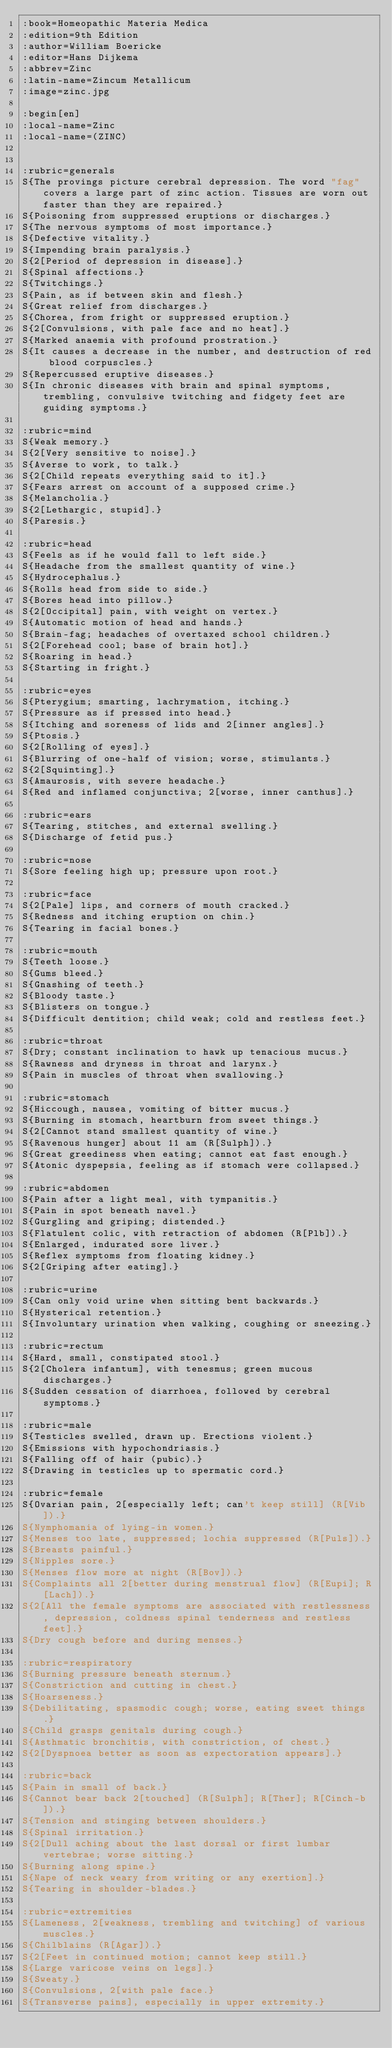<code> <loc_0><loc_0><loc_500><loc_500><_ObjectiveC_>:book=Homeopathic Materia Medica
:edition=9th Edition
:author=William Boericke
:editor=Hans Dijkema
:abbrev=Zinc
:latin-name=Zincum Metallicum
:image=zinc.jpg

:begin[en]
:local-name=Zinc
:local-name=(ZINC)


:rubric=generals
S{The provings picture cerebral depression. The word "fag" covers a large part of zinc action. Tissues are worn out faster than they are repaired.}
S{Poisoning from suppressed eruptions or discharges.}
S{The nervous symptoms of most importance.}
S{Defective vitality.}
S{Impending brain paralysis.}
S{2[Period of depression in disease].}
S{Spinal affections.}
S{Twitchings.}
S{Pain, as if between skin and flesh.}
S{Great relief from discharges.}
S{Chorea, from fright or suppressed eruption.}
S{2[Convulsions, with pale face and no heat].}
S{Marked anaemia with profound prostration.}
S{It causes a decrease in the number, and destruction of red blood corpuscles.}
S{Repercussed eruptive diseases.}
S{In chronic diseases with brain and spinal symptoms, trembling, convulsive twitching and fidgety feet are guiding symptoms.}

:rubric=mind
S{Weak memory.}
S{2[Very sensitive to noise].}
S{Averse to work, to talk.}
S{2[Child repeats everything said to it].}
S{Fears arrest on account of a supposed crime.}
S{Melancholia.}
S{2[Lethargic, stupid].}
S{Paresis.}

:rubric=head
S{Feels as if he would fall to left side.}
S{Headache from the smallest quantity of wine.}
S{Hydrocephalus.}
S{Rolls head from side to side.}
S{Bores head into pillow.}
S{2[Occipital] pain, with weight on vertex.}
S{Automatic motion of head and hands.}
S{Brain-fag; headaches of overtaxed school children.}
S{2[Forehead cool; base of brain hot].}
S{Roaring in head.}
S{Starting in fright.}

:rubric=eyes
S{Pterygium; smarting, lachrymation, itching.}
S{Pressure as if pressed into head.}
S{Itching and soreness of lids and 2[inner angles].}
S{Ptosis.}
S{2[Rolling of eyes].}
S{Blurring of one-half of vision; worse, stimulants.}
S{2[Squinting].}
S{Amaurosis, with severe headache.}
S{Red and inflamed conjunctiva; 2[worse, inner canthus].}

:rubric=ears
S{Tearing, stitches, and external swelling.}
S{Discharge of fetid pus.}

:rubric=nose
S{Sore feeling high up; pressure upon root.}

:rubric=face
S{2[Pale] lips, and corners of mouth cracked.}
S{Redness and itching eruption on chin.}
S{Tearing in facial bones.}

:rubric=mouth
S{Teeth loose.}
S{Gums bleed.}
S{Gnashing of teeth.}
S{Bloody taste.}
S{Blisters on tongue.}
S{Difficult dentition; child weak; cold and restless feet.}

:rubric=throat
S{Dry; constant inclination to hawk up tenacious mucus.}
S{Rawness and dryness in throat and larynx.}
S{Pain in muscles of throat when swallowing.}

:rubric=stomach
S{Hiccough, nausea, vomiting of bitter mucus.}
S{Burning in stomach, heartburn from sweet things.}
S{2[Cannot stand smallest quantity of wine.}
S{Ravenous hunger] about 11 am (R[Sulph]).}
S{Great greediness when eating; cannot eat fast enough.}
S{Atonic dyspepsia, feeling as if stomach were collapsed.}

:rubric=abdomen
S{Pain after a light meal, with tympanitis.}
S{Pain in spot beneath navel.}
S{Gurgling and griping; distended.}
S{Flatulent colic, with retraction of abdomen (R[Plb]).}
S{Enlarged, indurated sore liver.}
S{Reflex symptoms from floating kidney.}
S{2[Griping after eating].}

:rubric=urine
S{Can only void urine when sitting bent backwards.}
S{Hysterical retention.}
S{Involuntary urination when walking, coughing or sneezing.}

:rubric=rectum
S{Hard, small, constipated stool.}
S{2[Cholera infantum], with tenesmus; green mucous discharges.}
S{Sudden cessation of diarrhoea, followed by cerebral symptoms.}

:rubric=male
S{Testicles swelled, drawn up. Erections violent.}
S{Emissions with hypochondriasis.}
S{Falling off of hair (pubic).}
S{Drawing in testicles up to spermatic cord.}

:rubric=female
S{Ovarian pain, 2[especially left; can't keep still] (R[Vib]).}
S{Nymphomania of lying-in women.}
S{Menses too late, suppressed; lochia suppressed (R[Puls]).}
S{Breasts painful.}
S{Nipples sore.}
S{Menses flow more at night (R[Bov]).}
S{Complaints all 2[better during menstrual flow] (R[Eupi]; R[Lach]).}
S{2[All the female symptoms are associated with restlessness, depression, coldness spinal tenderness and restless feet].}
S{Dry cough before and during menses.}

:rubric=respiratory
S{Burning pressure beneath sternum.}
S{Constriction and cutting in chest.}
S{Hoarseness.}
S{Debilitating, spasmodic cough; worse, eating sweet things.}
S{Child grasps genitals during cough.}
S{Asthmatic bronchitis, with constriction, of chest.}
S{2[Dyspnoea better as soon as expectoration appears].}

:rubric=back
S{Pain in small of back.}
S{Cannot bear back 2[touched] (R[Sulph]; R[Ther]; R[Cinch-b]).}
S{Tension and stinging between shoulders.}
S{Spinal irritation.}
S{2[Dull aching about the last dorsal or first lumbar vertebrae; worse sitting.}
S{Burning along spine.}
S{Nape of neck weary from writing or any exertion].}
S{Tearing in shoulder-blades.}

:rubric=extremities
S{Lameness, 2[weakness, trembling and twitching] of various muscles.}
S{Chilblains (R[Agar]).}
S{2[Feet in continued motion; cannot keep still.}
S{Large varicose veins on legs].}
S{Sweaty.}
S{Convulsions, 2[with pale face.}
S{Transverse pains], especially in upper extremity.}</code> 